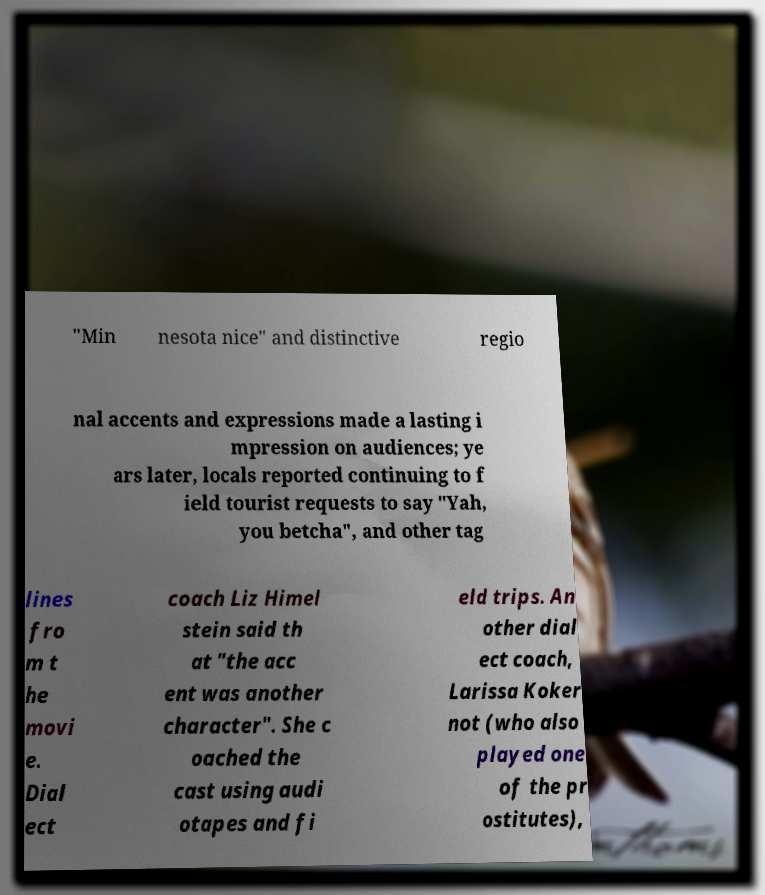What messages or text are displayed in this image? I need them in a readable, typed format. "Min nesota nice" and distinctive regio nal accents and expressions made a lasting i mpression on audiences; ye ars later, locals reported continuing to f ield tourist requests to say "Yah, you betcha", and other tag lines fro m t he movi e. Dial ect coach Liz Himel stein said th at "the acc ent was another character". She c oached the cast using audi otapes and fi eld trips. An other dial ect coach, Larissa Koker not (who also played one of the pr ostitutes), 